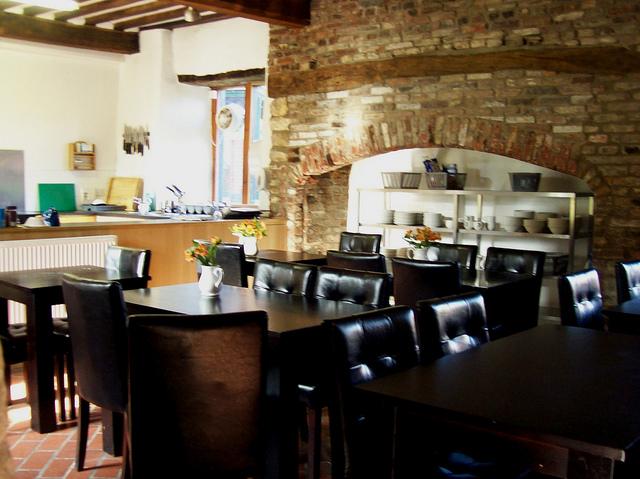How many chairs are in the scene?
Give a very brief answer. 16. Is the restaurant crowded?
Answer briefly. No. Is this a restaurant?
Quick response, please. Yes. Is this indoors?
Write a very short answer. Yes. 